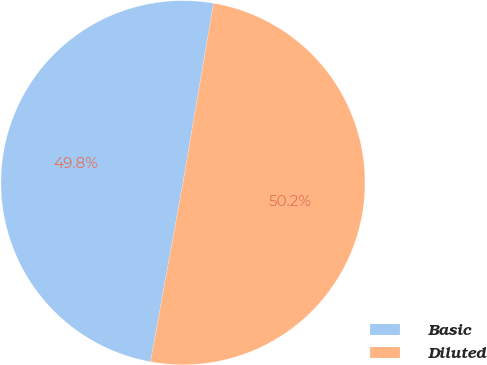Convert chart to OTSL. <chart><loc_0><loc_0><loc_500><loc_500><pie_chart><fcel>Basic<fcel>Diluted<nl><fcel>49.83%<fcel>50.17%<nl></chart> 